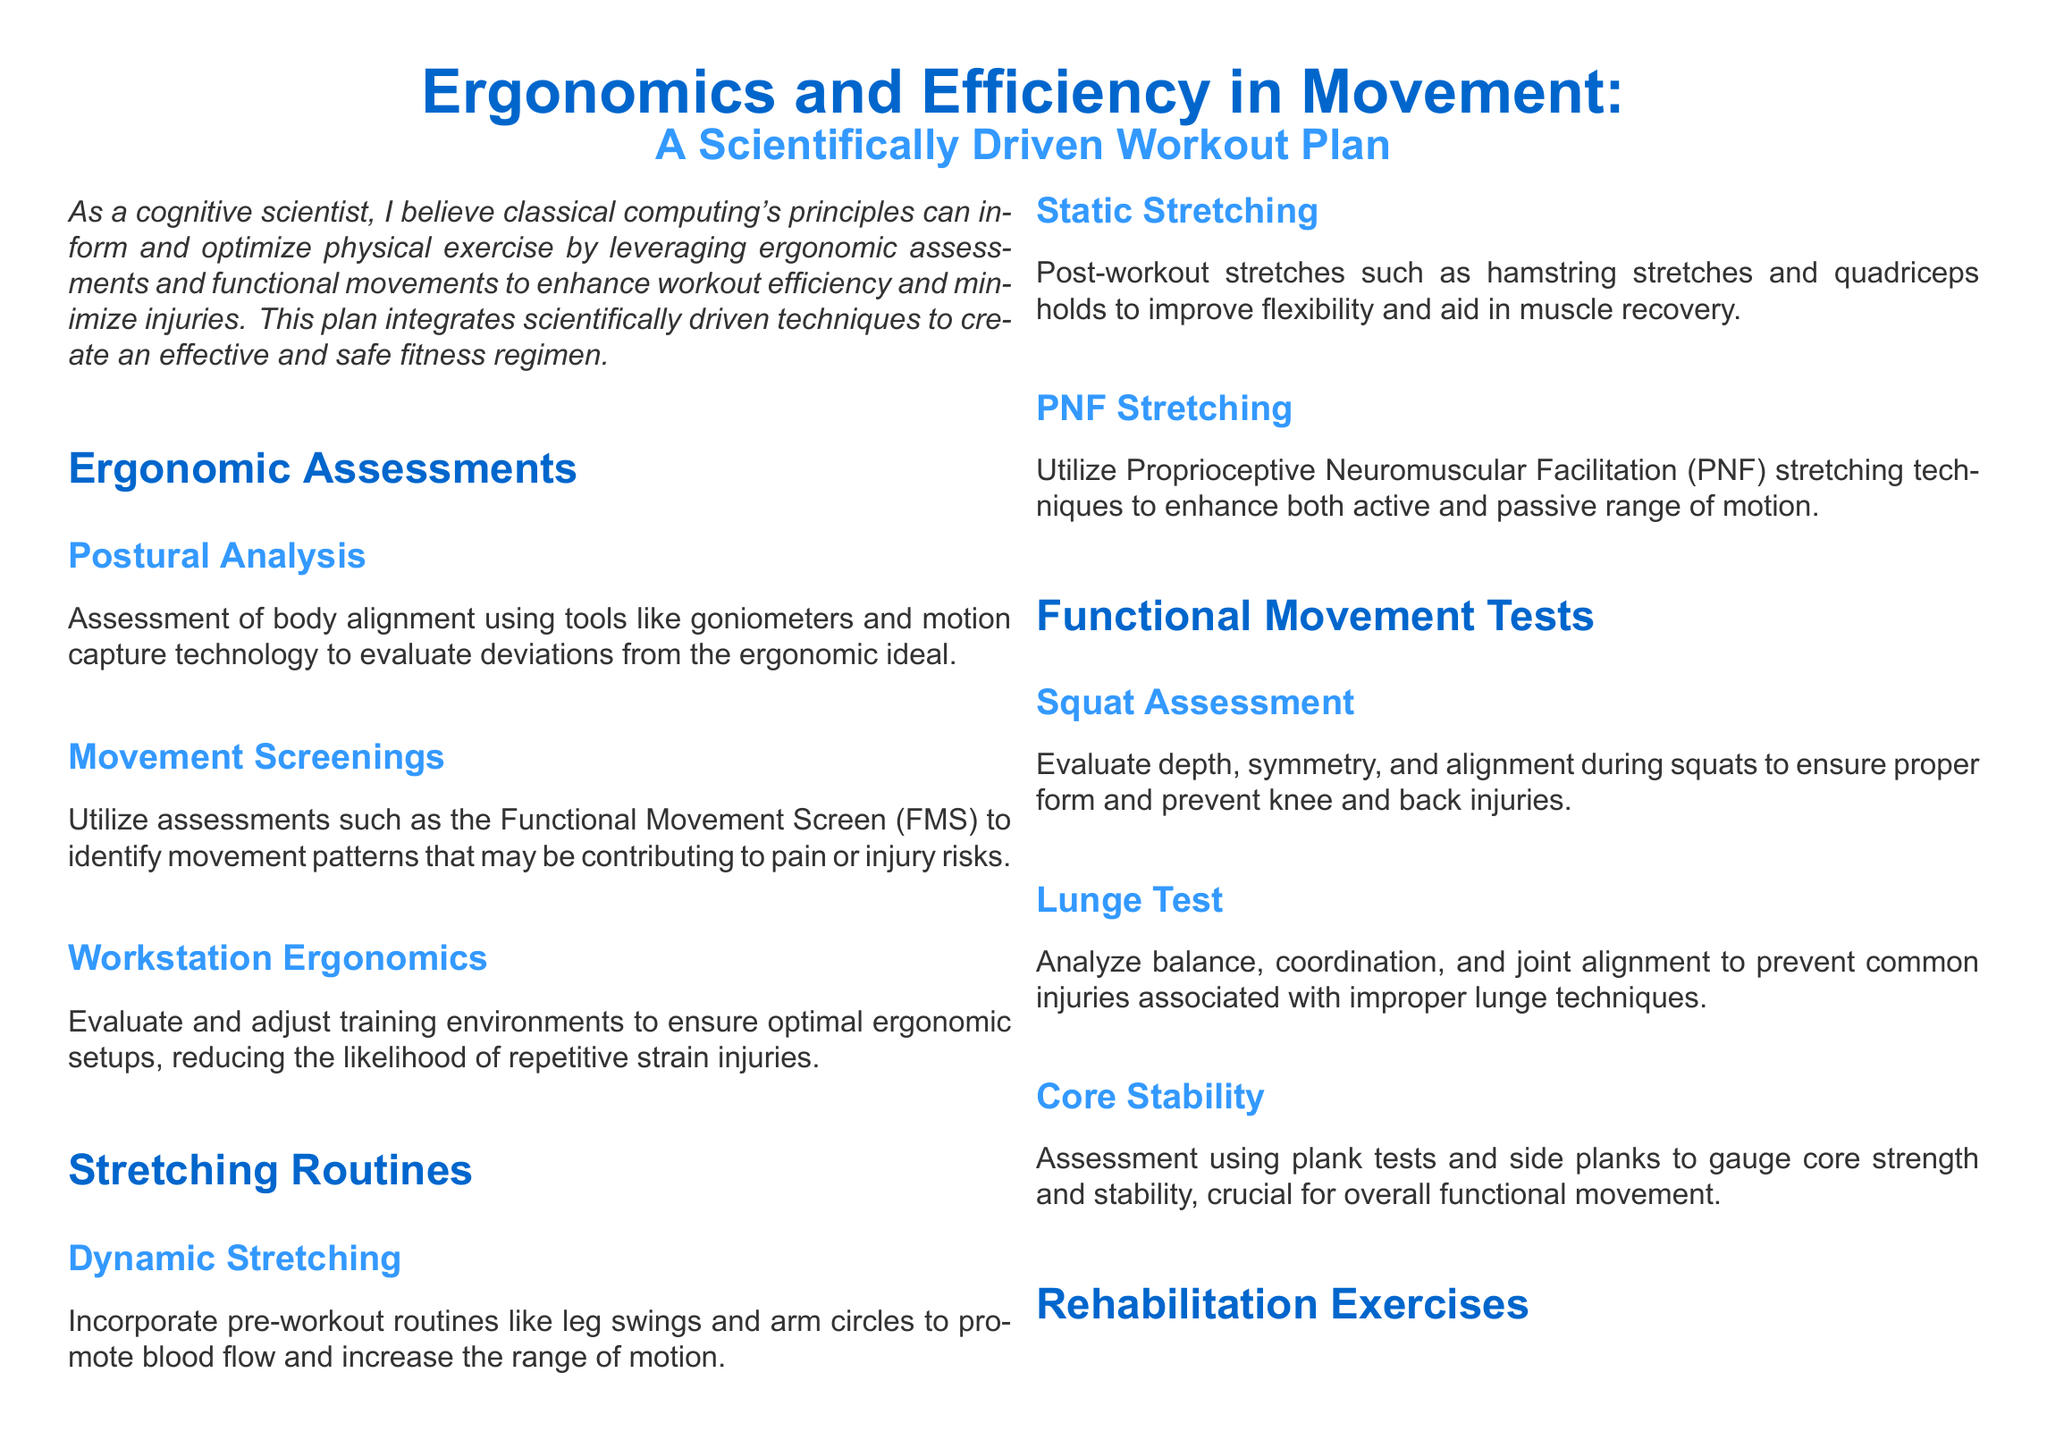What is the main focus of the document? The document emphasizes maximizing efficiency and minimizing injuries through the integration of ergonomics in movement.
Answer: Ergonomics and Efficiency in Movement What assessment tool is mentioned for postural analysis? Goniometers and motion capture technology are used to evaluate body alignment.
Answer: Goniometers What type of stretching is recommended for pre-workout? The document suggests dynamic stretching to promote blood flow and range of motion.
Answer: Dynamic Stretching What does FMS stand for in movement screenings? FMS refers to the Functional Movement Screen, used to identify movement patterns contributing to injury risks.
Answer: Functional Movement Screen Which exercise is used to assess core stability? Plank tests and side planks are utilized to gauge core strength and stability.
Answer: Plank tests What type of cardio is recommended for low-impact options? The document suggests swimming or cycling for cardiovascular health.
Answer: Swimming or cycling What stretching technique is highlighted for enhancing range of motion? Proprioceptive Neuromuscular Facilitation (PNF) stretching techniques are emphasized.
Answer: PNF Stretching What exercise is mentioned for glute activation? Banded clamshells are recommended for rebuilding strength in the glutes.
Answer: Banded clamshells 